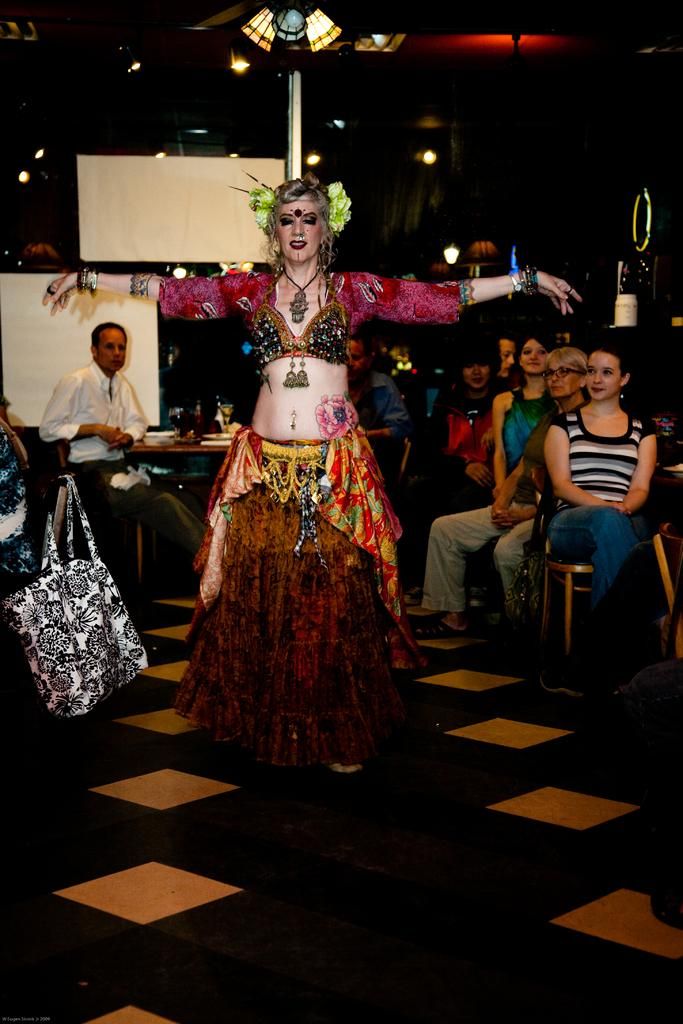What is the main subject of the image? There is a woman standing in the image. What are the other people in the image doing? There are people sitting on chairs in the image. What object can be seen near the people? There is a bag present in the image. What type of example can be seen in the image? There is no example present in the image; it features a woman standing and people sitting on chairs. Is there any indication of war in the image? There is no indication of war in the image; it is a peaceful scene with people standing and sitting. 